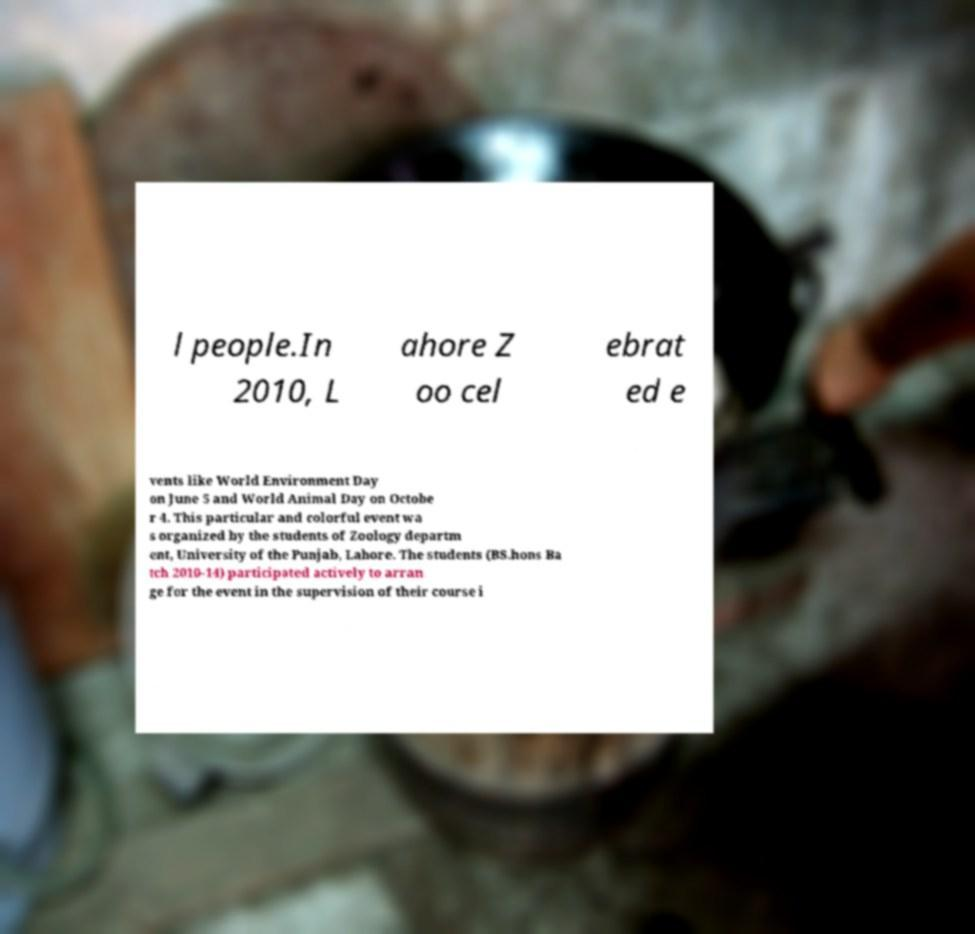Could you extract and type out the text from this image? l people.In 2010, L ahore Z oo cel ebrat ed e vents like World Environment Day on June 5 and World Animal Day on Octobe r 4. This particular and colorful event wa s organized by the students of Zoology departm ent, University of the Punjab, Lahore. The students (BS.hons Ba tch 2010-14) participated actively to arran ge for the event in the supervision of their course i 